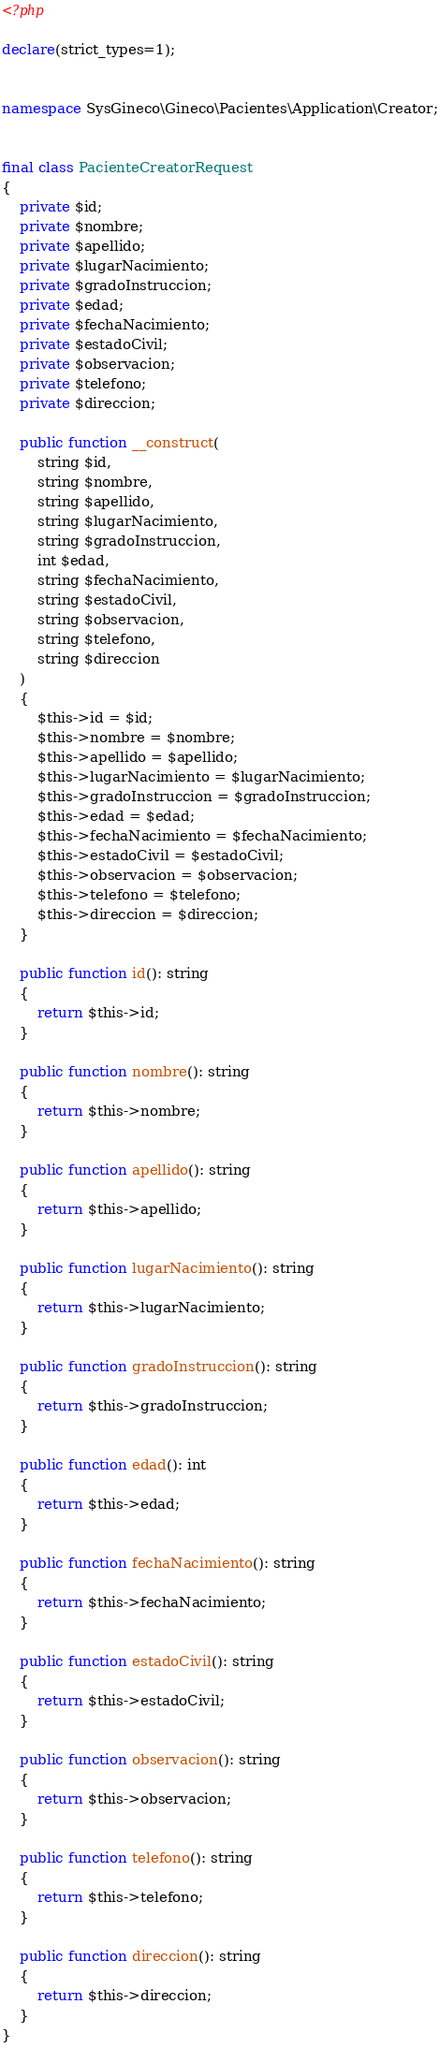<code> <loc_0><loc_0><loc_500><loc_500><_PHP_><?php

declare(strict_types=1);


namespace SysGineco\Gineco\Pacientes\Application\Creator;


final class PacienteCreatorRequest
{
    private $id;
    private $nombre;
    private $apellido;
    private $lugarNacimiento;
    private $gradoInstruccion;
    private $edad;
    private $fechaNacimiento;
    private $estadoCivil;
    private $observacion;
    private $telefono;
    private $direccion;

    public function __construct(
        string $id,
        string $nombre,
        string $apellido,
        string $lugarNacimiento,
        string $gradoInstruccion,
        int $edad,
        string $fechaNacimiento,
        string $estadoCivil,
        string $observacion,
        string $telefono,
        string $direccion
    )
    {
        $this->id = $id;
        $this->nombre = $nombre;
        $this->apellido = $apellido;
        $this->lugarNacimiento = $lugarNacimiento;
        $this->gradoInstruccion = $gradoInstruccion;
        $this->edad = $edad;
        $this->fechaNacimiento = $fechaNacimiento;
        $this->estadoCivil = $estadoCivil;
        $this->observacion = $observacion;
        $this->telefono = $telefono;
        $this->direccion = $direccion;
    }

    public function id(): string
    {
        return $this->id;
    }

    public function nombre(): string
    {
        return $this->nombre;
    }

    public function apellido(): string
    {
        return $this->apellido;
    }

    public function lugarNacimiento(): string
    {
        return $this->lugarNacimiento;
    }

    public function gradoInstruccion(): string
    {
        return $this->gradoInstruccion;
    }

    public function edad(): int
    {
        return $this->edad;
    }

    public function fechaNacimiento(): string
    {
        return $this->fechaNacimiento;
    }

    public function estadoCivil(): string
    {
        return $this->estadoCivil;
    }

    public function observacion(): string
    {
        return $this->observacion;
    }

    public function telefono(): string
    {
        return $this->telefono;
    }

    public function direccion(): string
    {
        return $this->direccion;
    }
}
</code> 